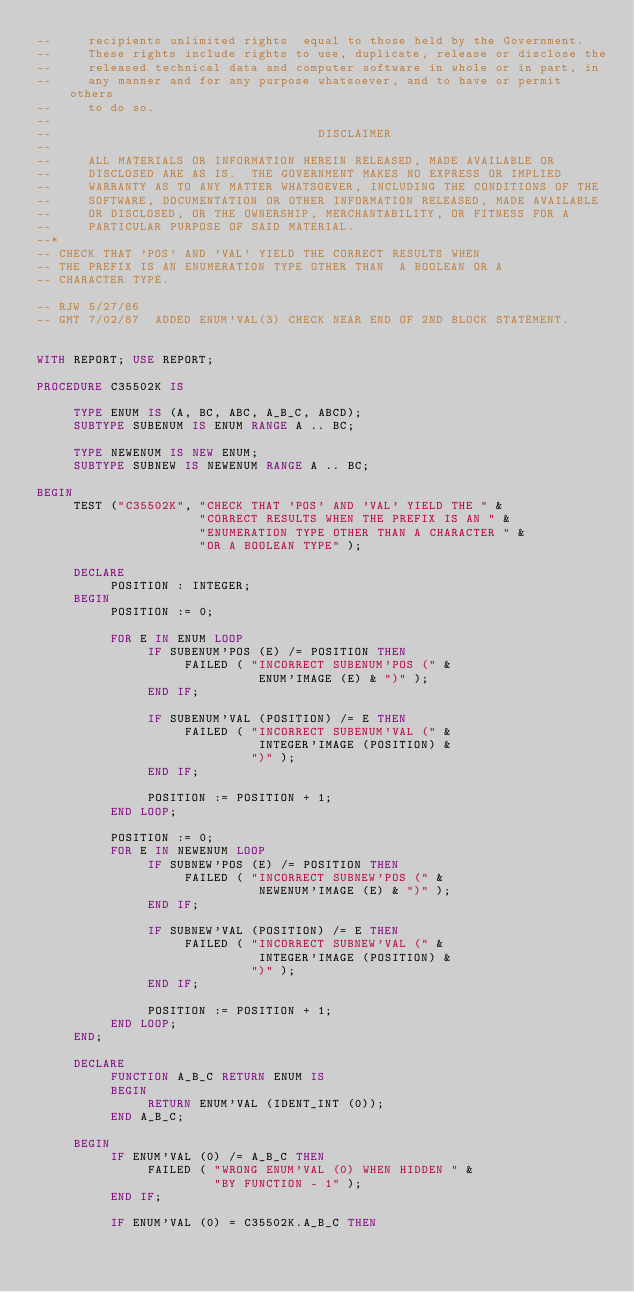Convert code to text. <code><loc_0><loc_0><loc_500><loc_500><_Ada_>--     recipients unlimited rights  equal to those held by the Government.  
--     These rights include rights to use, duplicate, release or disclose the 
--     released technical data and computer software in whole or in part, in 
--     any manner and for any purpose whatsoever, and to have or permit others 
--     to do so.
--
--                                    DISCLAIMER
--
--     ALL MATERIALS OR INFORMATION HEREIN RELEASED, MADE AVAILABLE OR
--     DISCLOSED ARE AS IS.  THE GOVERNMENT MAKES NO EXPRESS OR IMPLIED 
--     WARRANTY AS TO ANY MATTER WHATSOEVER, INCLUDING THE CONDITIONS OF THE
--     SOFTWARE, DOCUMENTATION OR OTHER INFORMATION RELEASED, MADE AVAILABLE 
--     OR DISCLOSED, OR THE OWNERSHIP, MERCHANTABILITY, OR FITNESS FOR A
--     PARTICULAR PURPOSE OF SAID MATERIAL.
--*
-- CHECK THAT 'POS' AND 'VAL' YIELD THE CORRECT RESULTS WHEN
-- THE PREFIX IS AN ENUMERATION TYPE OTHER THAN  A BOOLEAN OR A
-- CHARACTER TYPE.

-- RJW 5/27/86
-- GMT 7/02/87  ADDED ENUM'VAL(3) CHECK NEAR END OF 2ND BLOCK STATEMENT.


WITH REPORT; USE REPORT;

PROCEDURE C35502K IS

     TYPE ENUM IS (A, BC, ABC, A_B_C, ABCD);
     SUBTYPE SUBENUM IS ENUM RANGE A .. BC;

     TYPE NEWENUM IS NEW ENUM;
     SUBTYPE SUBNEW IS NEWENUM RANGE A .. BC;

BEGIN
     TEST ("C35502K", "CHECK THAT 'POS' AND 'VAL' YIELD THE " &
                      "CORRECT RESULTS WHEN THE PREFIX IS AN " &
                      "ENUMERATION TYPE OTHER THAN A CHARACTER " &
                      "OR A BOOLEAN TYPE" );

     DECLARE
          POSITION : INTEGER;
     BEGIN
          POSITION := 0;

          FOR E IN ENUM LOOP
               IF SUBENUM'POS (E) /= POSITION THEN
                    FAILED ( "INCORRECT SUBENUM'POS (" &
                              ENUM'IMAGE (E) & ")" );
               END IF;

               IF SUBENUM'VAL (POSITION) /= E THEN
                    FAILED ( "INCORRECT SUBENUM'VAL (" &
                              INTEGER'IMAGE (POSITION) &
                             ")" );
               END IF;

               POSITION := POSITION + 1;
          END LOOP;

          POSITION := 0;
          FOR E IN NEWENUM LOOP
               IF SUBNEW'POS (E) /= POSITION THEN
                    FAILED ( "INCORRECT SUBNEW'POS (" &
                              NEWENUM'IMAGE (E) & ")" );
               END IF;

               IF SUBNEW'VAL (POSITION) /= E THEN
                    FAILED ( "INCORRECT SUBNEW'VAL (" &
                              INTEGER'IMAGE (POSITION) &
                             ")" );
               END IF;

               POSITION := POSITION + 1;
          END LOOP;
     END;

     DECLARE
          FUNCTION A_B_C RETURN ENUM IS
          BEGIN
               RETURN ENUM'VAL (IDENT_INT (0));
          END A_B_C;

     BEGIN
          IF ENUM'VAL (0) /= A_B_C THEN
               FAILED ( "WRONG ENUM'VAL (0) WHEN HIDDEN " &
                        "BY FUNCTION - 1" );
          END IF;

          IF ENUM'VAL (0) = C35502K.A_B_C THEN</code> 